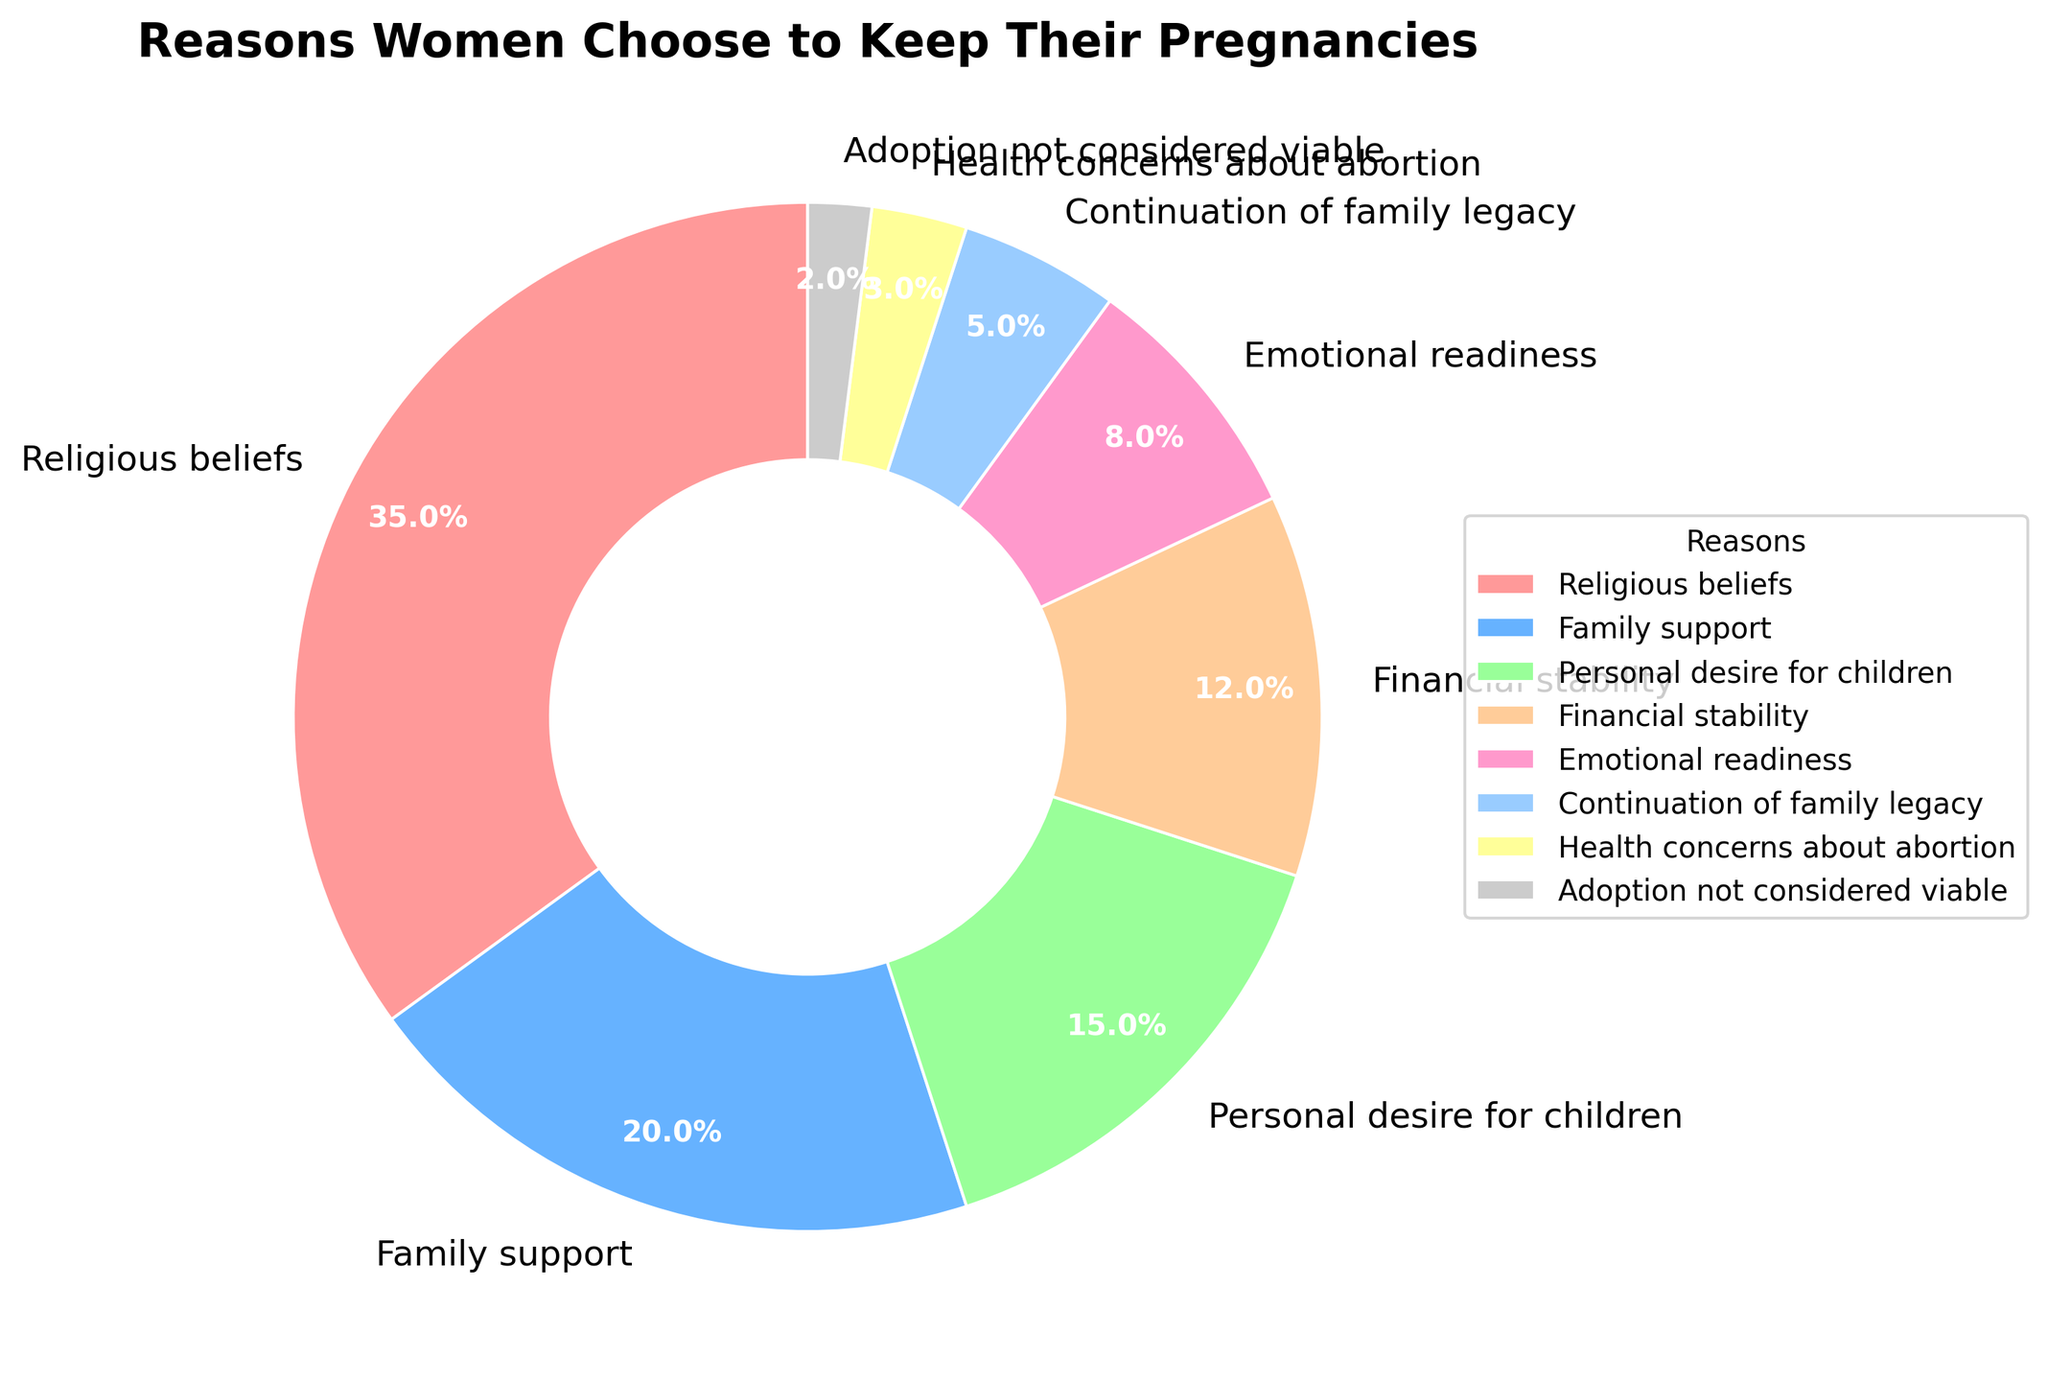Which reason accounts for the largest percentage of women choosing to keep their pregnancies? By examining the pie chart, we find that "Religious beliefs" covers the largest segment of the pie chart with the highest percentage at 35%.
Answer: Religious beliefs How much more significant is the "Religious beliefs" category compared to "Continuation of family legacy"? To find the difference, subtract the percentage of "Continuation of family legacy" (5%) from "Religious beliefs" (35%): 35% - 5% = 30%.
Answer: 30% What percentage of women chose to keep their pregnancies due to financial stability and family support combined? Combine the percentages of "Financial stability" (12%) and "Family support" (20%): 12% + 20% = 32%.
Answer: 32% Which reason contributes the least to women keeping their pregnancies? The smallest segment of the pie chart corresponds to "Adoption not considered viable" with a percentage of 2%.
Answer: Adoption not considered viable How many reasons have a percentage of less than 10%? By inspecting the pie chart, we see that "Emotional readiness" (8%), "Continuation of family legacy" (5%), "Health concerns about abortion" (3%), and "Adoption not considered viable" (2%) are all below 10%. That's four reasons in total.
Answer: 4 Which reason has nearly double the percentage of "Financial stability"? "Family support" has a percentage of 20%, which is close to double the percentage of "Financial stability" at 12%.
Answer: Family support Compare the percentages of "Personal desire for children" and "Emotional readiness." Which one is higher, and by how much? "Personal desire for children" has a percentage of 15%, while "Emotional readiness" has 8%. The difference is 15% - 8% = 7%.
Answer: Personal desire for children by 7% If you sum the percentages of reasons related to familial ties (Family support and Continuation of family legacy), what do you get? Add the percentages of "Family support" (20%) and "Continuation of family legacy" (5%): 20% + 5% = 25%.
Answer: 25% What color represents the "Health concerns about abortion" reason on the pie chart? In the pie chart, "Health concerns about abortion" is represented by the yellow segment.
Answer: Yellow 